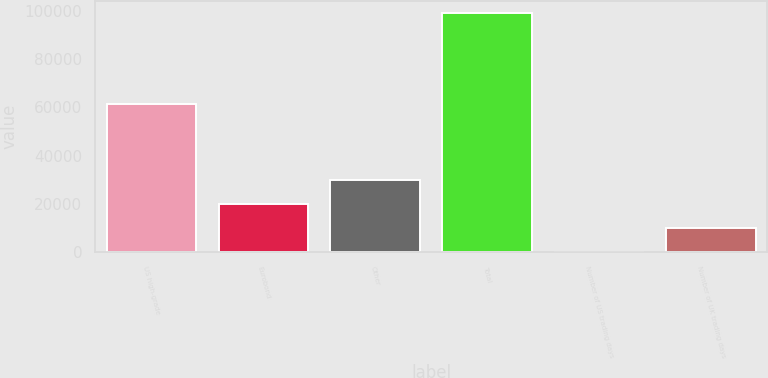Convert chart. <chart><loc_0><loc_0><loc_500><loc_500><bar_chart><fcel>US high-grade<fcel>Eurobond<fcel>Other<fcel>Total<fcel>Number of US trading days<fcel>Number of UK trading days<nl><fcel>61511<fcel>19889.2<fcel>29803.3<fcel>99202<fcel>61<fcel>9975.1<nl></chart> 